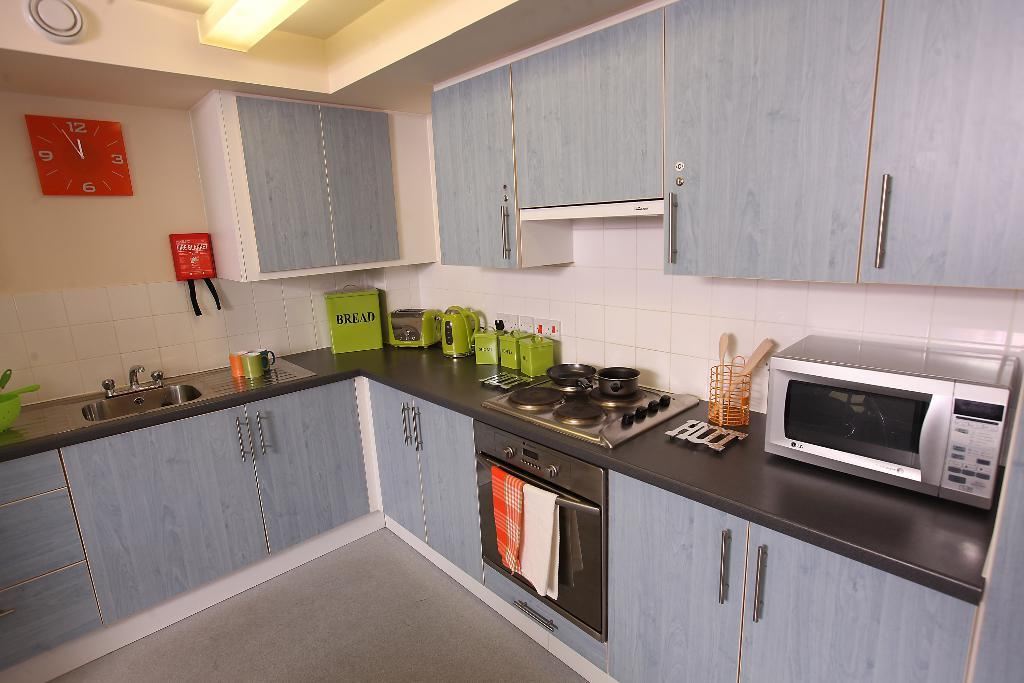<image>
Create a compact narrative representing the image presented. A kitchen with assorted items on the countertop, including a container labeled "BREAD". 